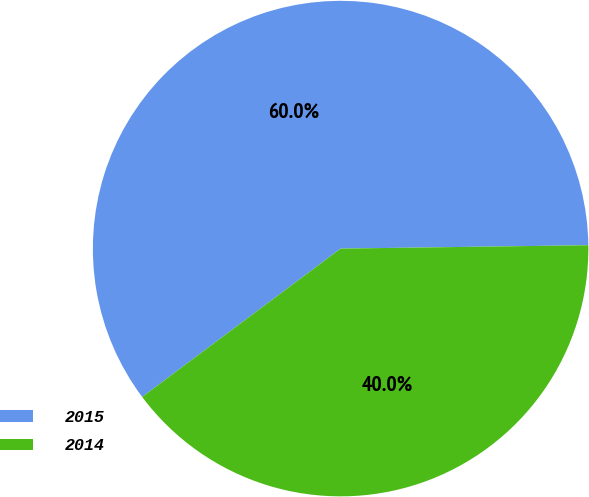<chart> <loc_0><loc_0><loc_500><loc_500><pie_chart><fcel>2015<fcel>2014<nl><fcel>60.0%<fcel>40.0%<nl></chart> 